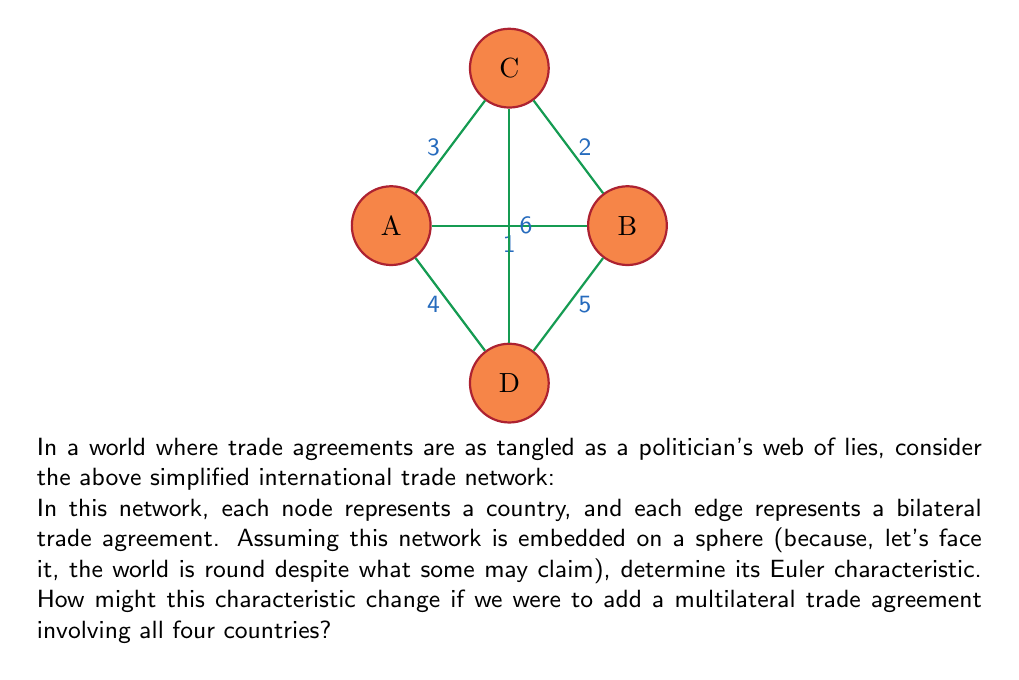Could you help me with this problem? Let's approach this step-by-step, shall we? Even a political scientist can appreciate the elegance of topology when it comes to understanding complex networks.

1) First, let's recall the Euler characteristic formula for a connected planar graph:
   $$\chi = V - E + F$$
   where $V$ is the number of vertices, $E$ is the number of edges, and $F$ is the number of faces.

2) In our trade network:
   - Vertices (V): We have 4 countries, so $V = 4$
   - Edges (E): There are 6 bilateral trade agreements, so $E = 6$

3) To find F, we need to count the faces, including the outer face:
   - We have 4 triangular faces (ABC, ABD, ACD, BCD)
   - Plus the outer face
   So, $F = 5$

4) Now, let's plug these values into our formula:
   $$\chi = V - E + F = 4 - 6 + 5 = 3$$

5) This result of 3 is consistent with the Euler characteristic of a sphere, which is 2. The discrepancy arises because our graph is embedded on the surface of the sphere, not the entire sphere itself.

6) If we were to add a multilateral trade agreement involving all four countries, it would be equivalent to adding a vertex in the center connected to all other vertices. This would create a tetrahedral structure:
   - New V = 5
   - New E = 6 (original) + 4 (new connections) = 10
   - New F = 4 (original triangular faces become tetrahedral faces)

7) The new Euler characteristic would be:
   $$\chi_{new} = V - E + F = 5 - 10 + 4 = -1$$

This negative Euler characteristic suggests a more complex topological structure, perhaps reflecting the increased complexity of multilateral trade relationships. It's almost as if adding more parties to an agreement makes things more complicated - who would have thought?
Answer: $\chi = 3$ (original), $\chi_{new} = -1$ (with multilateral agreement) 